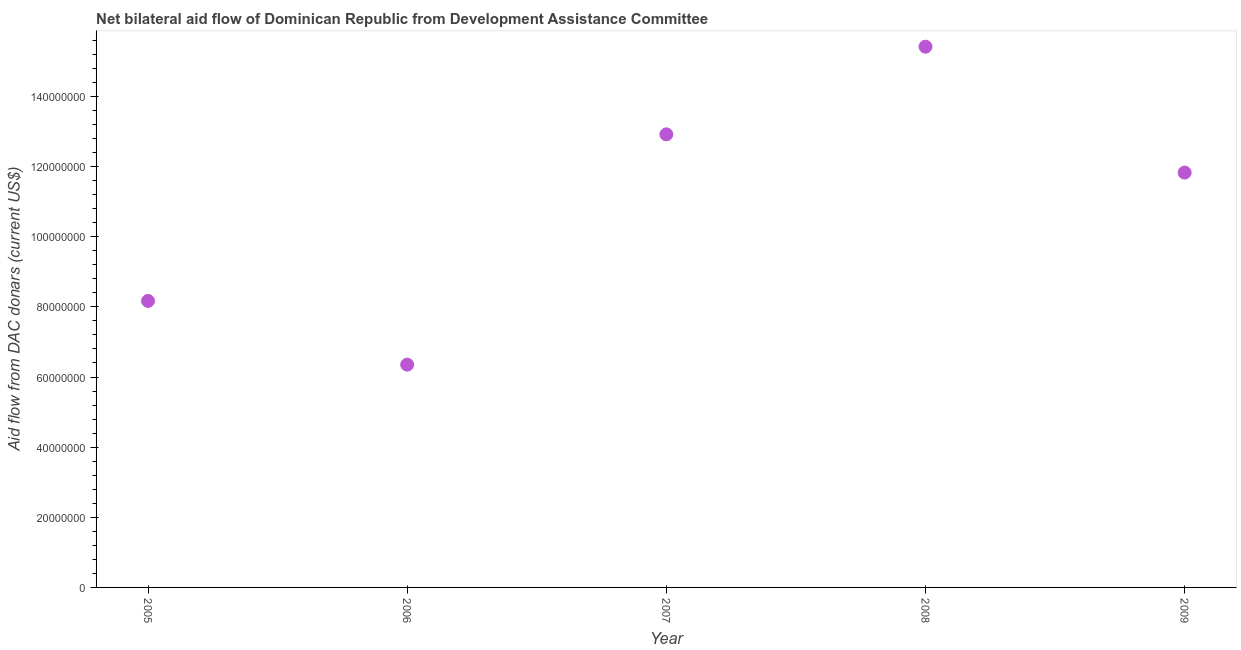What is the net bilateral aid flows from dac donors in 2009?
Keep it short and to the point. 1.18e+08. Across all years, what is the maximum net bilateral aid flows from dac donors?
Your answer should be compact. 1.54e+08. Across all years, what is the minimum net bilateral aid flows from dac donors?
Ensure brevity in your answer.  6.35e+07. In which year was the net bilateral aid flows from dac donors maximum?
Offer a terse response. 2008. In which year was the net bilateral aid flows from dac donors minimum?
Give a very brief answer. 2006. What is the sum of the net bilateral aid flows from dac donors?
Provide a short and direct response. 5.47e+08. What is the difference between the net bilateral aid flows from dac donors in 2005 and 2008?
Provide a short and direct response. -7.25e+07. What is the average net bilateral aid flows from dac donors per year?
Your answer should be very brief. 1.09e+08. What is the median net bilateral aid flows from dac donors?
Provide a succinct answer. 1.18e+08. Do a majority of the years between 2005 and 2007 (inclusive) have net bilateral aid flows from dac donors greater than 100000000 US$?
Give a very brief answer. No. What is the ratio of the net bilateral aid flows from dac donors in 2005 to that in 2007?
Give a very brief answer. 0.63. Is the net bilateral aid flows from dac donors in 2008 less than that in 2009?
Provide a succinct answer. No. What is the difference between the highest and the second highest net bilateral aid flows from dac donors?
Your answer should be very brief. 2.50e+07. What is the difference between the highest and the lowest net bilateral aid flows from dac donors?
Give a very brief answer. 9.07e+07. Are the values on the major ticks of Y-axis written in scientific E-notation?
Keep it short and to the point. No. Does the graph contain any zero values?
Keep it short and to the point. No. Does the graph contain grids?
Make the answer very short. No. What is the title of the graph?
Keep it short and to the point. Net bilateral aid flow of Dominican Republic from Development Assistance Committee. What is the label or title of the X-axis?
Provide a short and direct response. Year. What is the label or title of the Y-axis?
Provide a short and direct response. Aid flow from DAC donars (current US$). What is the Aid flow from DAC donars (current US$) in 2005?
Ensure brevity in your answer.  8.17e+07. What is the Aid flow from DAC donars (current US$) in 2006?
Provide a short and direct response. 6.35e+07. What is the Aid flow from DAC donars (current US$) in 2007?
Provide a succinct answer. 1.29e+08. What is the Aid flow from DAC donars (current US$) in 2008?
Ensure brevity in your answer.  1.54e+08. What is the Aid flow from DAC donars (current US$) in 2009?
Offer a very short reply. 1.18e+08. What is the difference between the Aid flow from DAC donars (current US$) in 2005 and 2006?
Offer a terse response. 1.82e+07. What is the difference between the Aid flow from DAC donars (current US$) in 2005 and 2007?
Give a very brief answer. -4.75e+07. What is the difference between the Aid flow from DAC donars (current US$) in 2005 and 2008?
Your answer should be very brief. -7.25e+07. What is the difference between the Aid flow from DAC donars (current US$) in 2005 and 2009?
Give a very brief answer. -3.66e+07. What is the difference between the Aid flow from DAC donars (current US$) in 2006 and 2007?
Give a very brief answer. -6.57e+07. What is the difference between the Aid flow from DAC donars (current US$) in 2006 and 2008?
Provide a succinct answer. -9.07e+07. What is the difference between the Aid flow from DAC donars (current US$) in 2006 and 2009?
Offer a very short reply. -5.48e+07. What is the difference between the Aid flow from DAC donars (current US$) in 2007 and 2008?
Your answer should be compact. -2.50e+07. What is the difference between the Aid flow from DAC donars (current US$) in 2007 and 2009?
Your response must be concise. 1.09e+07. What is the difference between the Aid flow from DAC donars (current US$) in 2008 and 2009?
Your answer should be very brief. 3.59e+07. What is the ratio of the Aid flow from DAC donars (current US$) in 2005 to that in 2006?
Provide a succinct answer. 1.29. What is the ratio of the Aid flow from DAC donars (current US$) in 2005 to that in 2007?
Offer a terse response. 0.63. What is the ratio of the Aid flow from DAC donars (current US$) in 2005 to that in 2008?
Your response must be concise. 0.53. What is the ratio of the Aid flow from DAC donars (current US$) in 2005 to that in 2009?
Your response must be concise. 0.69. What is the ratio of the Aid flow from DAC donars (current US$) in 2006 to that in 2007?
Make the answer very short. 0.49. What is the ratio of the Aid flow from DAC donars (current US$) in 2006 to that in 2008?
Your answer should be compact. 0.41. What is the ratio of the Aid flow from DAC donars (current US$) in 2006 to that in 2009?
Keep it short and to the point. 0.54. What is the ratio of the Aid flow from DAC donars (current US$) in 2007 to that in 2008?
Offer a very short reply. 0.84. What is the ratio of the Aid flow from DAC donars (current US$) in 2007 to that in 2009?
Provide a succinct answer. 1.09. What is the ratio of the Aid flow from DAC donars (current US$) in 2008 to that in 2009?
Your answer should be very brief. 1.3. 